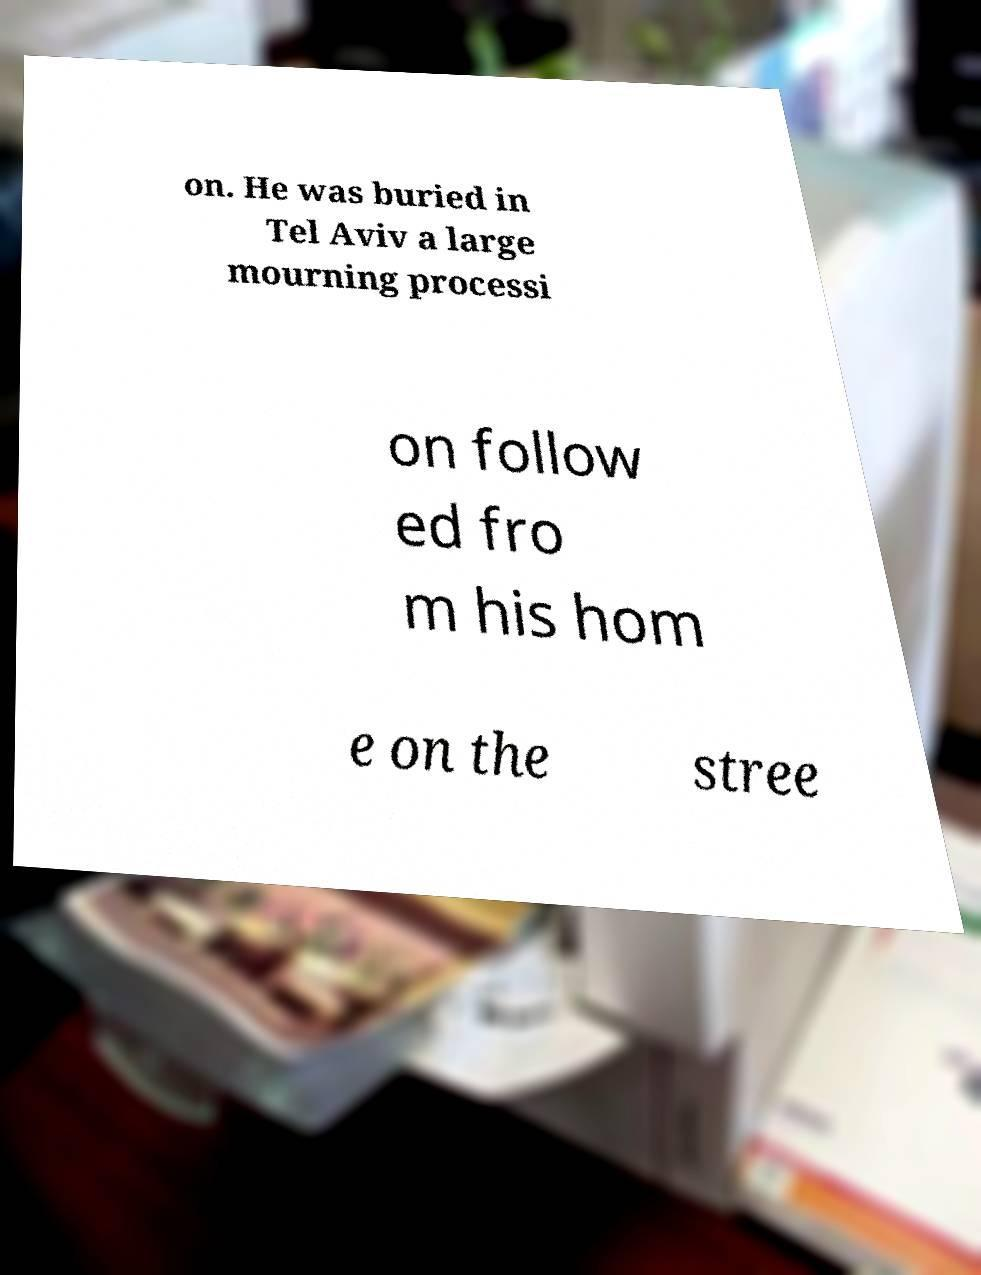What messages or text are displayed in this image? I need them in a readable, typed format. on. He was buried in Tel Aviv a large mourning processi on follow ed fro m his hom e on the stree 